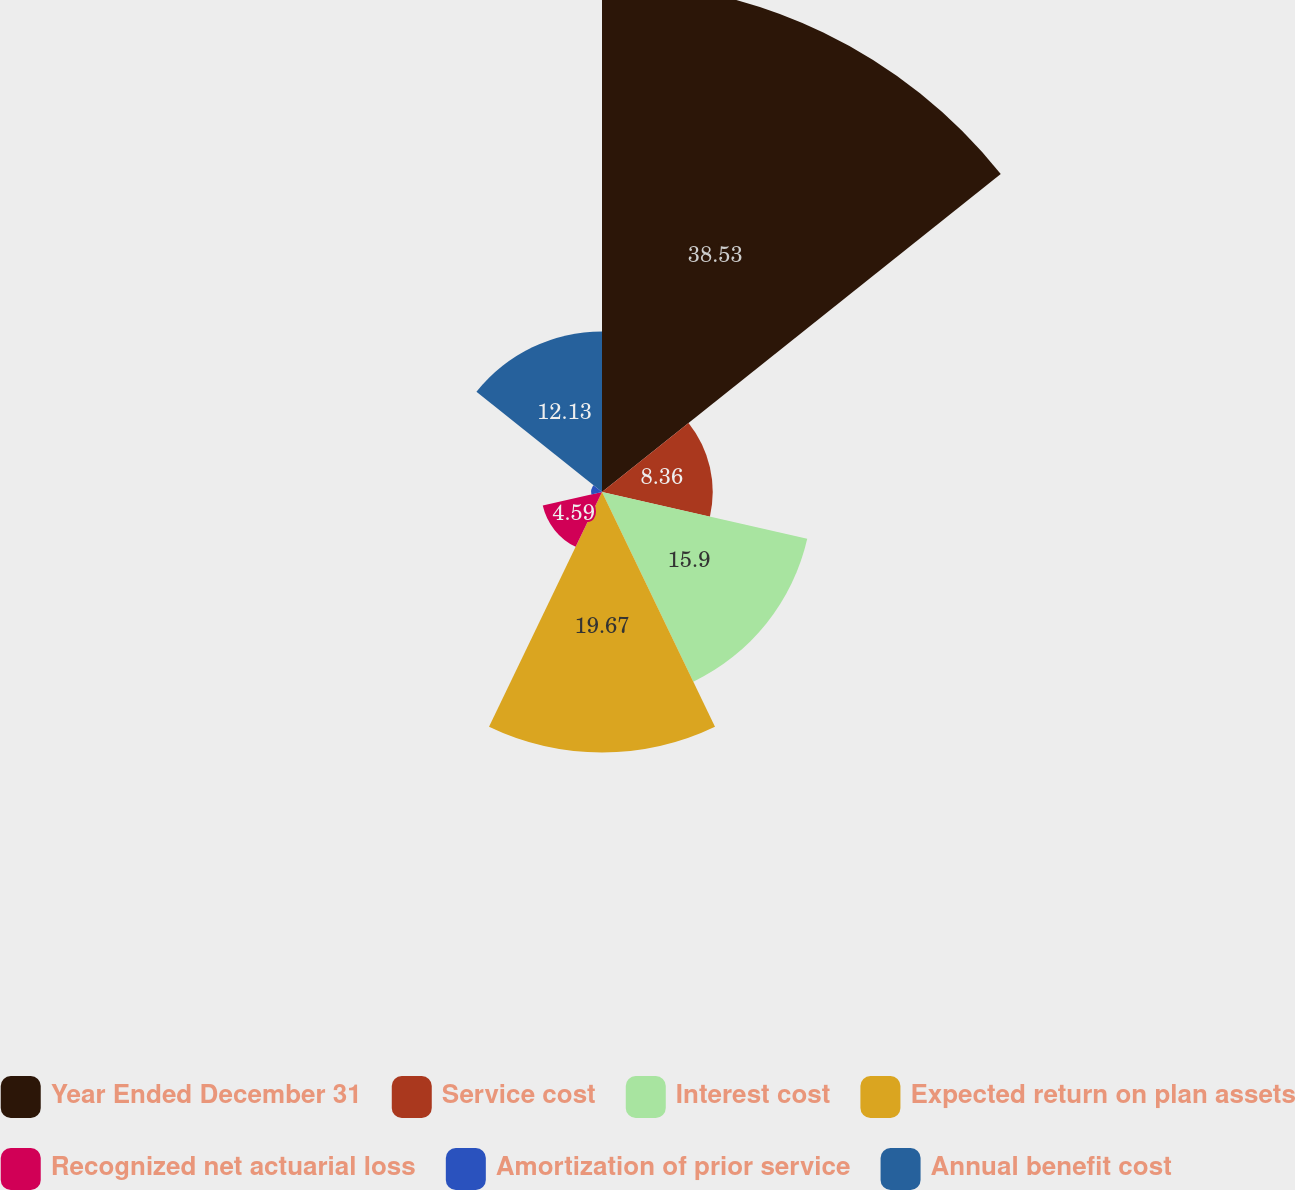Convert chart to OTSL. <chart><loc_0><loc_0><loc_500><loc_500><pie_chart><fcel>Year Ended December 31<fcel>Service cost<fcel>Interest cost<fcel>Expected return on plan assets<fcel>Recognized net actuarial loss<fcel>Amortization of prior service<fcel>Annual benefit cost<nl><fcel>38.52%<fcel>8.36%<fcel>15.9%<fcel>19.67%<fcel>4.59%<fcel>0.82%<fcel>12.13%<nl></chart> 